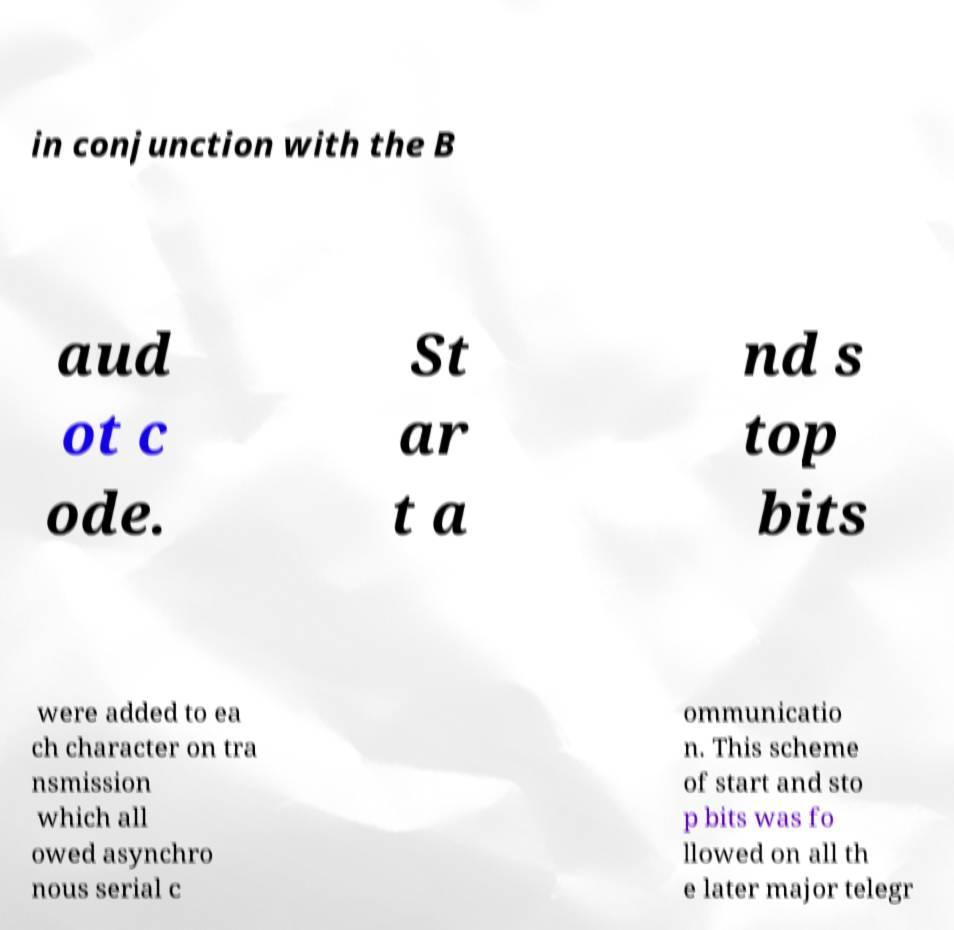Please read and relay the text visible in this image. What does it say? in conjunction with the B aud ot c ode. St ar t a nd s top bits were added to ea ch character on tra nsmission which all owed asynchro nous serial c ommunicatio n. This scheme of start and sto p bits was fo llowed on all th e later major telegr 